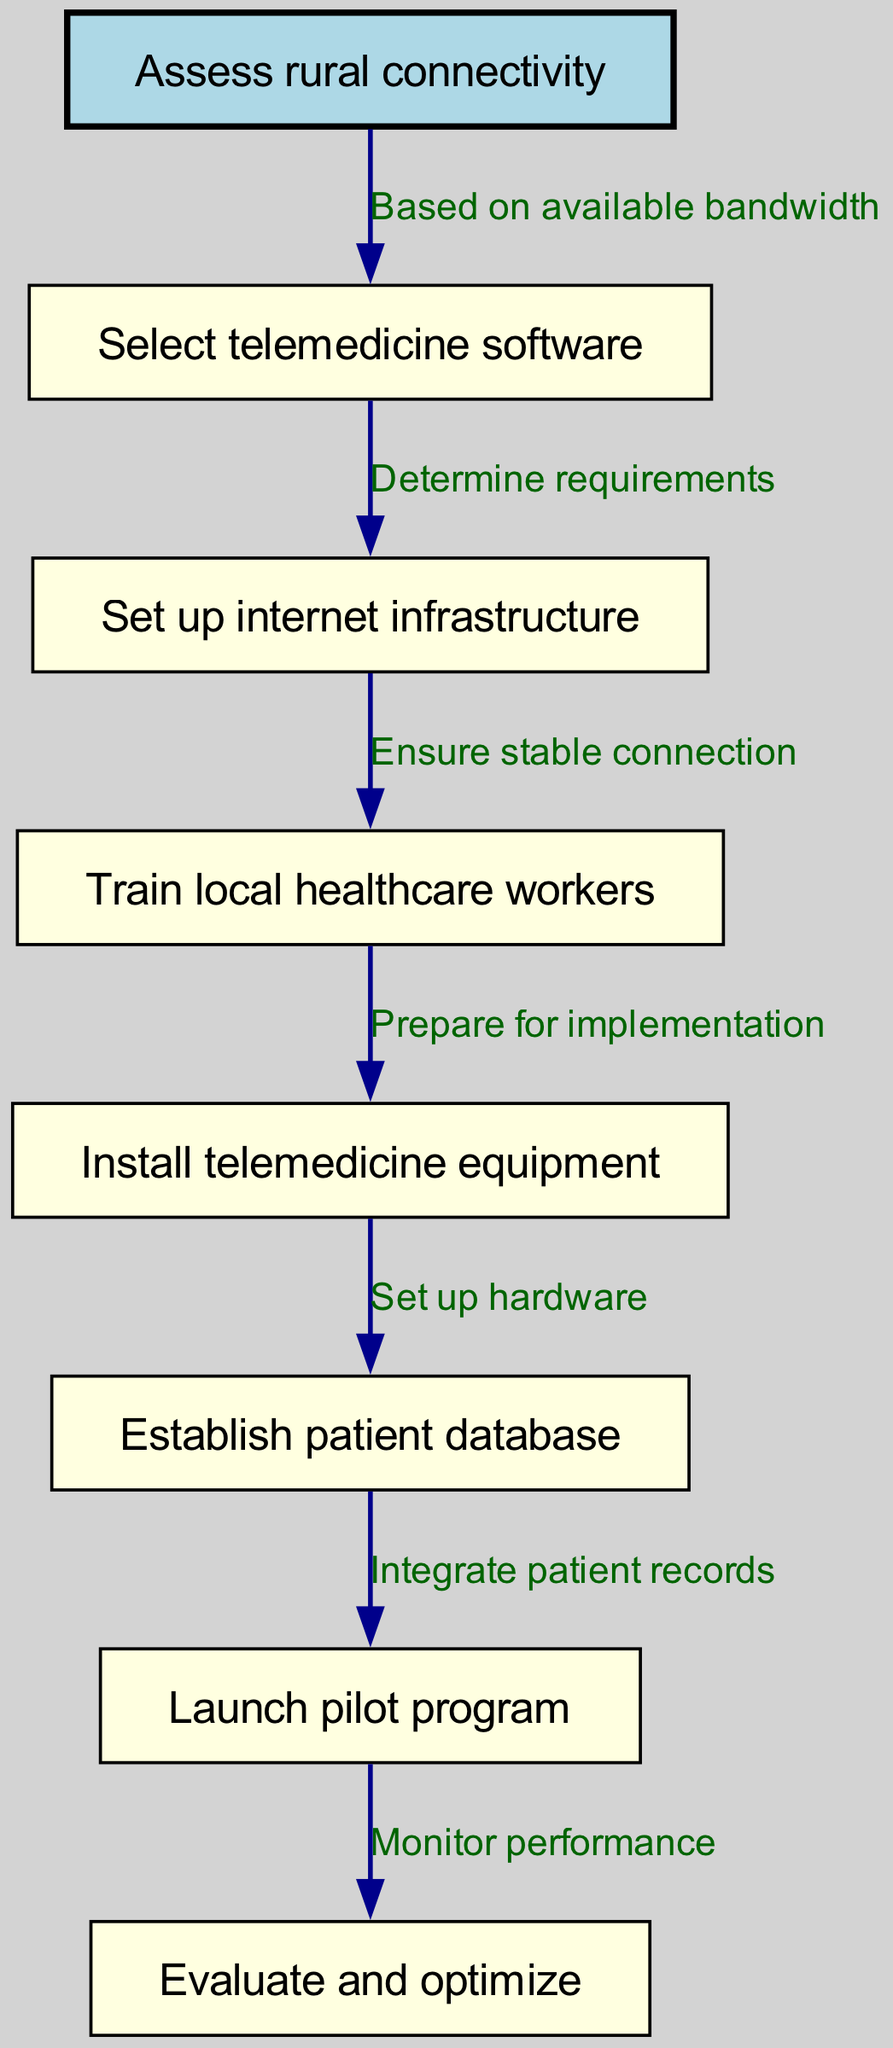What is the first step in the clinical pathway? The diagram starts at the node labeled "Assess rural connectivity", indicating it is the first step in the clinical pathway for implementing telemedicine services.
Answer: Assess rural connectivity How many nodes are there in total? The diagram lists eight nodes, including the starting node and all subsequent steps in the clinical pathway.
Answer: 8 What is the relationship between "Set up internet infrastructure" and "Train local healthcare workers"? There is a directed edge from "Set up internet infrastructure" to "Train local healthcare workers" indicating that once the internet infrastructure is set up, training for local healthcare workers can commence.
Answer: Ensure stable connection What indicates the prerequisites for "Install telemedicine equipment"? The diagram shows that "Train local healthcare workers" must be completed before moving to "Install telemedicine equipment", indicating that training is a prerequisite for equipment installation.
Answer: Prepare for implementation What step follows the "Launch pilot program"? According to the diagram, the next step after "Launch pilot program" is "Evaluate and optimize", indicating that evaluation occurs after the pilot is launched.
Answer: Evaluate and optimize What label connects "Select telemedicine software" to "Set up internet infrastructure"? The label on the edge connecting these two nodes is "Determine requirements", which signifies that the selection of software precedes and informs the setup of internet infrastructure.
Answer: Determine requirements How many edges are in the diagram? The diagram presents seven edges, each representing a relationship between consecutive steps in the clinical pathway.
Answer: 7 What step comes after "Establish patient database"? From the diagram, the step following "Establish patient database" is "Launch pilot program", demonstrating the sequential flow of the clinical pathway.
Answer: Launch pilot program 